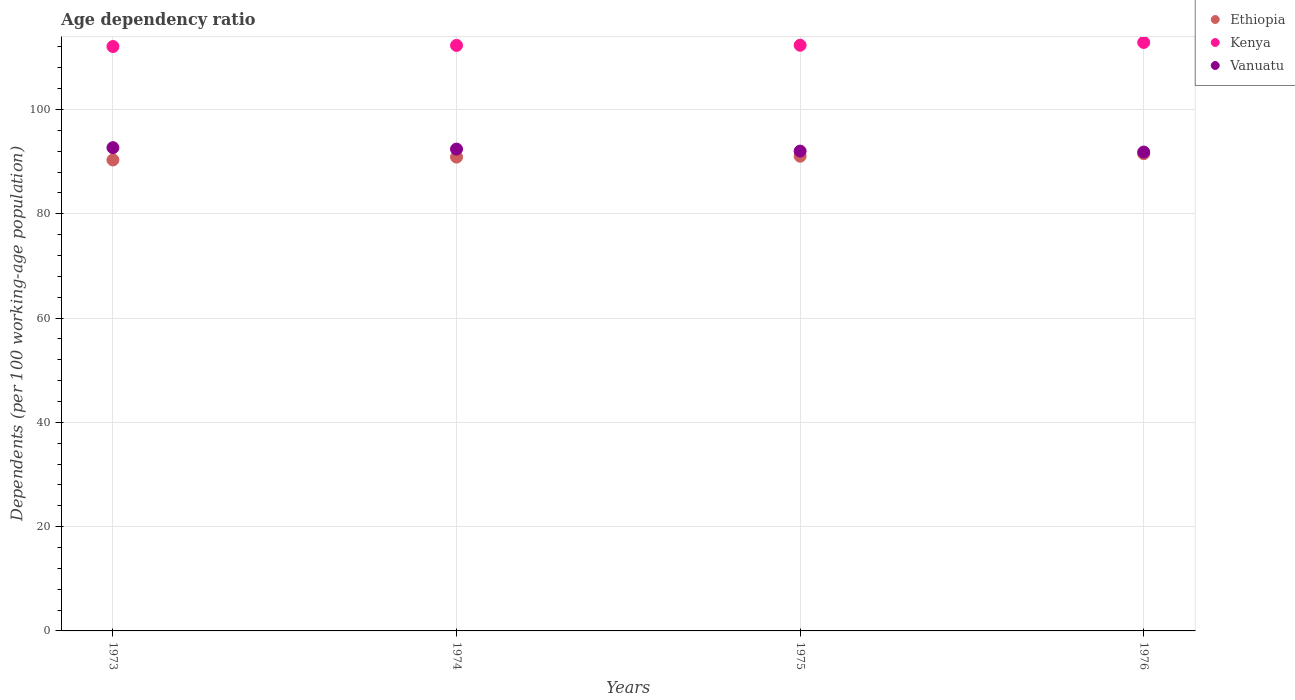What is the age dependency ratio in in Vanuatu in 1973?
Offer a very short reply. 92.67. Across all years, what is the maximum age dependency ratio in in Vanuatu?
Your response must be concise. 92.67. Across all years, what is the minimum age dependency ratio in in Ethiopia?
Your answer should be very brief. 90.32. In which year was the age dependency ratio in in Kenya maximum?
Your answer should be very brief. 1976. What is the total age dependency ratio in in Vanuatu in the graph?
Offer a terse response. 368.92. What is the difference between the age dependency ratio in in Ethiopia in 1973 and that in 1976?
Offer a very short reply. -1.2. What is the difference between the age dependency ratio in in Vanuatu in 1975 and the age dependency ratio in in Kenya in 1974?
Your answer should be compact. -20.27. What is the average age dependency ratio in in Ethiopia per year?
Provide a short and direct response. 90.93. In the year 1975, what is the difference between the age dependency ratio in in Kenya and age dependency ratio in in Ethiopia?
Ensure brevity in your answer.  21.28. What is the ratio of the age dependency ratio in in Kenya in 1974 to that in 1976?
Provide a succinct answer. 0.99. What is the difference between the highest and the second highest age dependency ratio in in Kenya?
Your answer should be very brief. 0.54. What is the difference between the highest and the lowest age dependency ratio in in Vanuatu?
Make the answer very short. 0.84. Does the age dependency ratio in in Kenya monotonically increase over the years?
Provide a succinct answer. Yes. How many dotlines are there?
Provide a succinct answer. 3. How many years are there in the graph?
Keep it short and to the point. 4. What is the difference between two consecutive major ticks on the Y-axis?
Offer a very short reply. 20. Are the values on the major ticks of Y-axis written in scientific E-notation?
Your response must be concise. No. Does the graph contain grids?
Offer a very short reply. Yes. How many legend labels are there?
Provide a short and direct response. 3. What is the title of the graph?
Provide a short and direct response. Age dependency ratio. Does "Guyana" appear as one of the legend labels in the graph?
Provide a short and direct response. No. What is the label or title of the X-axis?
Your answer should be very brief. Years. What is the label or title of the Y-axis?
Offer a terse response. Dependents (per 100 working-age population). What is the Dependents (per 100 working-age population) of Ethiopia in 1973?
Provide a short and direct response. 90.32. What is the Dependents (per 100 working-age population) of Kenya in 1973?
Your answer should be very brief. 112.07. What is the Dependents (per 100 working-age population) in Vanuatu in 1973?
Your response must be concise. 92.67. What is the Dependents (per 100 working-age population) in Ethiopia in 1974?
Your response must be concise. 90.87. What is the Dependents (per 100 working-age population) of Kenya in 1974?
Offer a terse response. 112.28. What is the Dependents (per 100 working-age population) in Vanuatu in 1974?
Give a very brief answer. 92.4. What is the Dependents (per 100 working-age population) of Ethiopia in 1975?
Your answer should be compact. 91.03. What is the Dependents (per 100 working-age population) in Kenya in 1975?
Your answer should be very brief. 112.31. What is the Dependents (per 100 working-age population) of Vanuatu in 1975?
Your answer should be very brief. 92.02. What is the Dependents (per 100 working-age population) in Ethiopia in 1976?
Offer a very short reply. 91.52. What is the Dependents (per 100 working-age population) in Kenya in 1976?
Give a very brief answer. 112.85. What is the Dependents (per 100 working-age population) of Vanuatu in 1976?
Your answer should be compact. 91.83. Across all years, what is the maximum Dependents (per 100 working-age population) in Ethiopia?
Make the answer very short. 91.52. Across all years, what is the maximum Dependents (per 100 working-age population) in Kenya?
Ensure brevity in your answer.  112.85. Across all years, what is the maximum Dependents (per 100 working-age population) of Vanuatu?
Provide a short and direct response. 92.67. Across all years, what is the minimum Dependents (per 100 working-age population) of Ethiopia?
Provide a short and direct response. 90.32. Across all years, what is the minimum Dependents (per 100 working-age population) of Kenya?
Make the answer very short. 112.07. Across all years, what is the minimum Dependents (per 100 working-age population) in Vanuatu?
Your answer should be very brief. 91.83. What is the total Dependents (per 100 working-age population) in Ethiopia in the graph?
Your answer should be compact. 363.74. What is the total Dependents (per 100 working-age population) of Kenya in the graph?
Offer a very short reply. 449.51. What is the total Dependents (per 100 working-age population) of Vanuatu in the graph?
Make the answer very short. 368.92. What is the difference between the Dependents (per 100 working-age population) of Ethiopia in 1973 and that in 1974?
Ensure brevity in your answer.  -0.55. What is the difference between the Dependents (per 100 working-age population) in Kenya in 1973 and that in 1974?
Make the answer very short. -0.21. What is the difference between the Dependents (per 100 working-age population) in Vanuatu in 1973 and that in 1974?
Your response must be concise. 0.27. What is the difference between the Dependents (per 100 working-age population) of Ethiopia in 1973 and that in 1975?
Keep it short and to the point. -0.72. What is the difference between the Dependents (per 100 working-age population) of Kenya in 1973 and that in 1975?
Offer a terse response. -0.25. What is the difference between the Dependents (per 100 working-age population) of Vanuatu in 1973 and that in 1975?
Give a very brief answer. 0.66. What is the difference between the Dependents (per 100 working-age population) of Ethiopia in 1973 and that in 1976?
Your answer should be very brief. -1.2. What is the difference between the Dependents (per 100 working-age population) of Kenya in 1973 and that in 1976?
Your answer should be compact. -0.78. What is the difference between the Dependents (per 100 working-age population) of Vanuatu in 1973 and that in 1976?
Your answer should be compact. 0.84. What is the difference between the Dependents (per 100 working-age population) of Ethiopia in 1974 and that in 1975?
Your answer should be very brief. -0.17. What is the difference between the Dependents (per 100 working-age population) in Kenya in 1974 and that in 1975?
Your answer should be compact. -0.03. What is the difference between the Dependents (per 100 working-age population) in Vanuatu in 1974 and that in 1975?
Offer a terse response. 0.38. What is the difference between the Dependents (per 100 working-age population) of Ethiopia in 1974 and that in 1976?
Your response must be concise. -0.66. What is the difference between the Dependents (per 100 working-age population) in Kenya in 1974 and that in 1976?
Your answer should be very brief. -0.57. What is the difference between the Dependents (per 100 working-age population) of Vanuatu in 1974 and that in 1976?
Offer a terse response. 0.57. What is the difference between the Dependents (per 100 working-age population) of Ethiopia in 1975 and that in 1976?
Offer a terse response. -0.49. What is the difference between the Dependents (per 100 working-age population) of Kenya in 1975 and that in 1976?
Provide a short and direct response. -0.54. What is the difference between the Dependents (per 100 working-age population) of Vanuatu in 1975 and that in 1976?
Offer a terse response. 0.18. What is the difference between the Dependents (per 100 working-age population) of Ethiopia in 1973 and the Dependents (per 100 working-age population) of Kenya in 1974?
Offer a very short reply. -21.97. What is the difference between the Dependents (per 100 working-age population) of Ethiopia in 1973 and the Dependents (per 100 working-age population) of Vanuatu in 1974?
Provide a succinct answer. -2.08. What is the difference between the Dependents (per 100 working-age population) in Kenya in 1973 and the Dependents (per 100 working-age population) in Vanuatu in 1974?
Provide a succinct answer. 19.67. What is the difference between the Dependents (per 100 working-age population) in Ethiopia in 1973 and the Dependents (per 100 working-age population) in Kenya in 1975?
Your answer should be very brief. -22. What is the difference between the Dependents (per 100 working-age population) of Ethiopia in 1973 and the Dependents (per 100 working-age population) of Vanuatu in 1975?
Provide a short and direct response. -1.7. What is the difference between the Dependents (per 100 working-age population) in Kenya in 1973 and the Dependents (per 100 working-age population) in Vanuatu in 1975?
Give a very brief answer. 20.05. What is the difference between the Dependents (per 100 working-age population) in Ethiopia in 1973 and the Dependents (per 100 working-age population) in Kenya in 1976?
Your answer should be compact. -22.53. What is the difference between the Dependents (per 100 working-age population) in Ethiopia in 1973 and the Dependents (per 100 working-age population) in Vanuatu in 1976?
Keep it short and to the point. -1.52. What is the difference between the Dependents (per 100 working-age population) in Kenya in 1973 and the Dependents (per 100 working-age population) in Vanuatu in 1976?
Offer a terse response. 20.24. What is the difference between the Dependents (per 100 working-age population) of Ethiopia in 1974 and the Dependents (per 100 working-age population) of Kenya in 1975?
Your response must be concise. -21.45. What is the difference between the Dependents (per 100 working-age population) of Ethiopia in 1974 and the Dependents (per 100 working-age population) of Vanuatu in 1975?
Your answer should be compact. -1.15. What is the difference between the Dependents (per 100 working-age population) in Kenya in 1974 and the Dependents (per 100 working-age population) in Vanuatu in 1975?
Offer a terse response. 20.27. What is the difference between the Dependents (per 100 working-age population) of Ethiopia in 1974 and the Dependents (per 100 working-age population) of Kenya in 1976?
Your answer should be very brief. -21.98. What is the difference between the Dependents (per 100 working-age population) in Ethiopia in 1974 and the Dependents (per 100 working-age population) in Vanuatu in 1976?
Give a very brief answer. -0.97. What is the difference between the Dependents (per 100 working-age population) in Kenya in 1974 and the Dependents (per 100 working-age population) in Vanuatu in 1976?
Your response must be concise. 20.45. What is the difference between the Dependents (per 100 working-age population) in Ethiopia in 1975 and the Dependents (per 100 working-age population) in Kenya in 1976?
Keep it short and to the point. -21.82. What is the difference between the Dependents (per 100 working-age population) of Ethiopia in 1975 and the Dependents (per 100 working-age population) of Vanuatu in 1976?
Provide a succinct answer. -0.8. What is the difference between the Dependents (per 100 working-age population) in Kenya in 1975 and the Dependents (per 100 working-age population) in Vanuatu in 1976?
Your answer should be compact. 20.48. What is the average Dependents (per 100 working-age population) in Ethiopia per year?
Keep it short and to the point. 90.93. What is the average Dependents (per 100 working-age population) in Kenya per year?
Provide a short and direct response. 112.38. What is the average Dependents (per 100 working-age population) in Vanuatu per year?
Your response must be concise. 92.23. In the year 1973, what is the difference between the Dependents (per 100 working-age population) of Ethiopia and Dependents (per 100 working-age population) of Kenya?
Your answer should be compact. -21.75. In the year 1973, what is the difference between the Dependents (per 100 working-age population) of Ethiopia and Dependents (per 100 working-age population) of Vanuatu?
Make the answer very short. -2.36. In the year 1973, what is the difference between the Dependents (per 100 working-age population) in Kenya and Dependents (per 100 working-age population) in Vanuatu?
Offer a very short reply. 19.39. In the year 1974, what is the difference between the Dependents (per 100 working-age population) in Ethiopia and Dependents (per 100 working-age population) in Kenya?
Ensure brevity in your answer.  -21.42. In the year 1974, what is the difference between the Dependents (per 100 working-age population) in Ethiopia and Dependents (per 100 working-age population) in Vanuatu?
Provide a short and direct response. -1.54. In the year 1974, what is the difference between the Dependents (per 100 working-age population) in Kenya and Dependents (per 100 working-age population) in Vanuatu?
Make the answer very short. 19.88. In the year 1975, what is the difference between the Dependents (per 100 working-age population) in Ethiopia and Dependents (per 100 working-age population) in Kenya?
Offer a terse response. -21.28. In the year 1975, what is the difference between the Dependents (per 100 working-age population) in Ethiopia and Dependents (per 100 working-age population) in Vanuatu?
Provide a succinct answer. -0.98. In the year 1975, what is the difference between the Dependents (per 100 working-age population) in Kenya and Dependents (per 100 working-age population) in Vanuatu?
Offer a terse response. 20.3. In the year 1976, what is the difference between the Dependents (per 100 working-age population) in Ethiopia and Dependents (per 100 working-age population) in Kenya?
Your response must be concise. -21.33. In the year 1976, what is the difference between the Dependents (per 100 working-age population) of Ethiopia and Dependents (per 100 working-age population) of Vanuatu?
Your answer should be compact. -0.31. In the year 1976, what is the difference between the Dependents (per 100 working-age population) in Kenya and Dependents (per 100 working-age population) in Vanuatu?
Ensure brevity in your answer.  21.02. What is the ratio of the Dependents (per 100 working-age population) in Ethiopia in 1973 to that in 1974?
Make the answer very short. 0.99. What is the ratio of the Dependents (per 100 working-age population) in Kenya in 1973 to that in 1975?
Offer a terse response. 1. What is the ratio of the Dependents (per 100 working-age population) of Vanuatu in 1973 to that in 1975?
Your answer should be very brief. 1.01. What is the ratio of the Dependents (per 100 working-age population) in Ethiopia in 1973 to that in 1976?
Keep it short and to the point. 0.99. What is the ratio of the Dependents (per 100 working-age population) in Kenya in 1973 to that in 1976?
Make the answer very short. 0.99. What is the ratio of the Dependents (per 100 working-age population) of Vanuatu in 1973 to that in 1976?
Offer a very short reply. 1.01. What is the ratio of the Dependents (per 100 working-age population) in Ethiopia in 1974 to that in 1975?
Your answer should be compact. 1. What is the ratio of the Dependents (per 100 working-age population) in Vanuatu in 1974 to that in 1975?
Your answer should be very brief. 1. What is the ratio of the Dependents (per 100 working-age population) in Ethiopia in 1974 to that in 1976?
Make the answer very short. 0.99. What is the ratio of the Dependents (per 100 working-age population) of Kenya in 1974 to that in 1976?
Your response must be concise. 0.99. What is the ratio of the Dependents (per 100 working-age population) of Ethiopia in 1975 to that in 1976?
Provide a short and direct response. 0.99. What is the ratio of the Dependents (per 100 working-age population) in Kenya in 1975 to that in 1976?
Offer a terse response. 1. What is the difference between the highest and the second highest Dependents (per 100 working-age population) of Ethiopia?
Make the answer very short. 0.49. What is the difference between the highest and the second highest Dependents (per 100 working-age population) in Kenya?
Offer a terse response. 0.54. What is the difference between the highest and the second highest Dependents (per 100 working-age population) in Vanuatu?
Your answer should be compact. 0.27. What is the difference between the highest and the lowest Dependents (per 100 working-age population) of Ethiopia?
Your answer should be very brief. 1.2. What is the difference between the highest and the lowest Dependents (per 100 working-age population) of Kenya?
Ensure brevity in your answer.  0.78. What is the difference between the highest and the lowest Dependents (per 100 working-age population) in Vanuatu?
Offer a terse response. 0.84. 